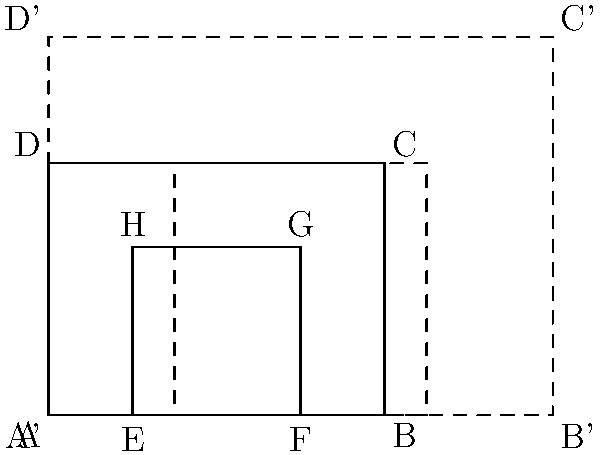As a shopkeeper familiar with traditional Swiss chalet designs, you're helping a local architect create a scaled-up version of a basic chalet floor plan. The original design ABCD represents the outer walls, with EFGH as an inner room. If the entire floor plan is dilated by a scale factor of 1.5, what is the area of the new inner room E'F'G'H' in terms of the original inner room's area? Let's approach this step-by-step:

1) First, recall that when a shape is dilated by a scale factor k, its linear dimensions (length and width) are multiplied by k.

2) In this case, the scale factor is 1.5. So, all lengths in the new floor plan will be 1.5 times the original lengths.

3) However, area is two-dimensional. When a shape is dilated by a scale factor k, its area is multiplied by $k^2$.

4) Therefore, the area of the new inner room E'F'G'H' will be $(1.5)^2 = 2.25$ times the area of the original inner room EFGH.

5) We can express this mathematically as:

   Area of E'F'G'H' = $2.25 \times$ Area of EFGH

This means the new inner room will be 2.25 times larger than the original inner room.
Answer: $2.25 \times$ original area 